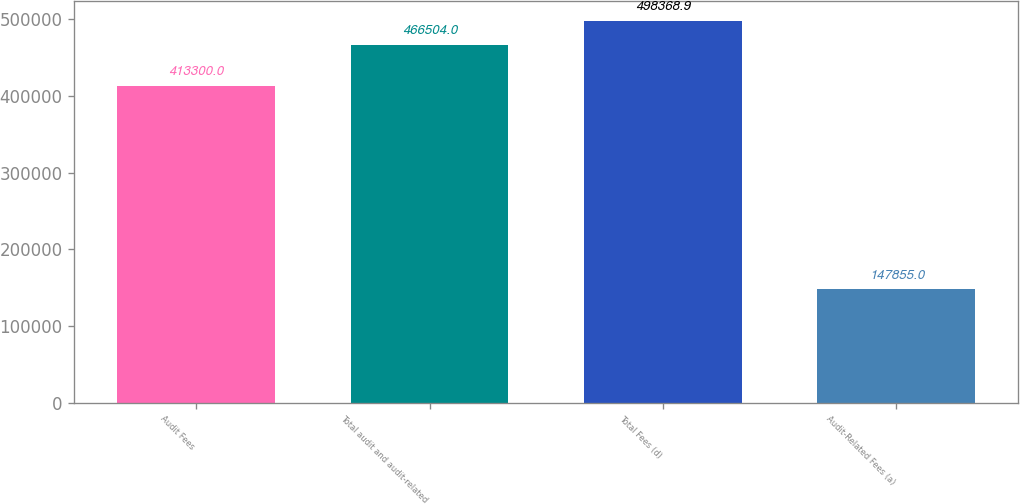Convert chart to OTSL. <chart><loc_0><loc_0><loc_500><loc_500><bar_chart><fcel>Audit Fees<fcel>Total audit and audit-related<fcel>Total Fees (d)<fcel>Audit-Related Fees (a)<nl><fcel>413300<fcel>466504<fcel>498369<fcel>147855<nl></chart> 